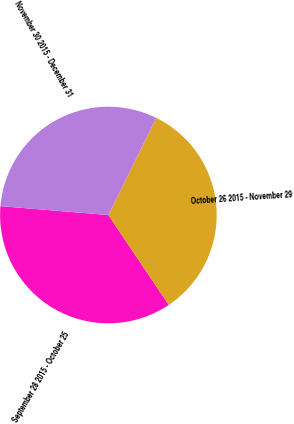Convert chart to OTSL. <chart><loc_0><loc_0><loc_500><loc_500><pie_chart><fcel>September 28 2015 - October 25<fcel>October 26 2015 - November 29<fcel>November 30 2015 - December 31<nl><fcel>35.73%<fcel>33.28%<fcel>30.99%<nl></chart> 